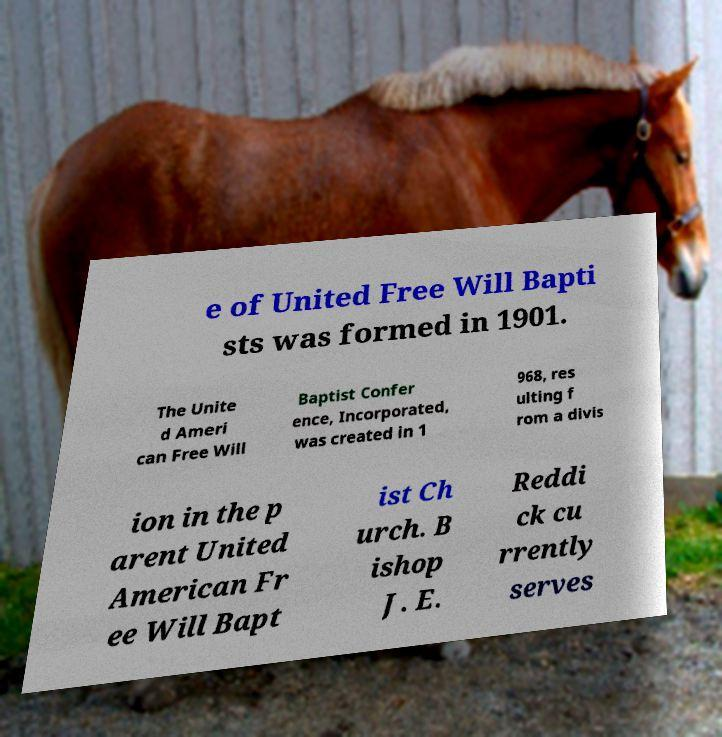Could you extract and type out the text from this image? e of United Free Will Bapti sts was formed in 1901. The Unite d Ameri can Free Will Baptist Confer ence, Incorporated, was created in 1 968, res ulting f rom a divis ion in the p arent United American Fr ee Will Bapt ist Ch urch. B ishop J. E. Reddi ck cu rrently serves 